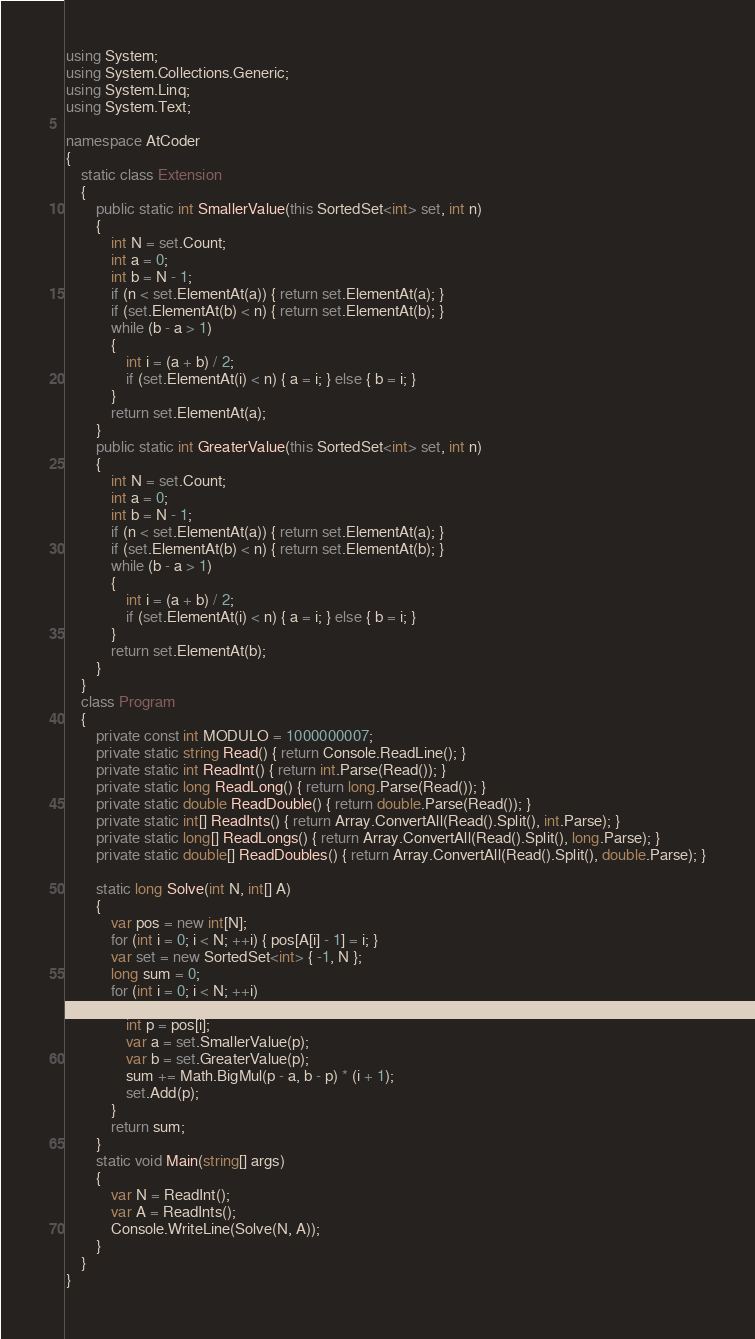<code> <loc_0><loc_0><loc_500><loc_500><_C#_>using System;
using System.Collections.Generic;
using System.Linq;
using System.Text;

namespace AtCoder
{
    static class Extension
    {
        public static int SmallerValue(this SortedSet<int> set, int n)
        {
            int N = set.Count;
            int a = 0;
            int b = N - 1;
            if (n < set.ElementAt(a)) { return set.ElementAt(a); }
            if (set.ElementAt(b) < n) { return set.ElementAt(b); }
            while (b - a > 1)
            {
                int i = (a + b) / 2;
                if (set.ElementAt(i) < n) { a = i; } else { b = i; }
            }
            return set.ElementAt(a);
        }
        public static int GreaterValue(this SortedSet<int> set, int n)
        {
            int N = set.Count;
            int a = 0;
            int b = N - 1;
            if (n < set.ElementAt(a)) { return set.ElementAt(a); }
            if (set.ElementAt(b) < n) { return set.ElementAt(b); }
            while (b - a > 1)
            {
                int i = (a + b) / 2;
                if (set.ElementAt(i) < n) { a = i; } else { b = i; }
            }
            return set.ElementAt(b);
        }
    }
    class Program
    {
        private const int MODULO = 1000000007;
        private static string Read() { return Console.ReadLine(); }
        private static int ReadInt() { return int.Parse(Read()); }
        private static long ReadLong() { return long.Parse(Read()); }
        private static double ReadDouble() { return double.Parse(Read()); }
        private static int[] ReadInts() { return Array.ConvertAll(Read().Split(), int.Parse); }
        private static long[] ReadLongs() { return Array.ConvertAll(Read().Split(), long.Parse); }
        private static double[] ReadDoubles() { return Array.ConvertAll(Read().Split(), double.Parse); }

        static long Solve(int N, int[] A)
        {
            var pos = new int[N];
            for (int i = 0; i < N; ++i) { pos[A[i] - 1] = i; }
            var set = new SortedSet<int> { -1, N };
            long sum = 0;
            for (int i = 0; i < N; ++i)
            {
                int p = pos[i];
                var a = set.SmallerValue(p);
                var b = set.GreaterValue(p);
                sum += Math.BigMul(p - a, b - p) * (i + 1);
                set.Add(p);
            }
            return sum;
        }
        static void Main(string[] args)
        {
            var N = ReadInt();
            var A = ReadInts();
            Console.WriteLine(Solve(N, A));
        }
    }
}
</code> 